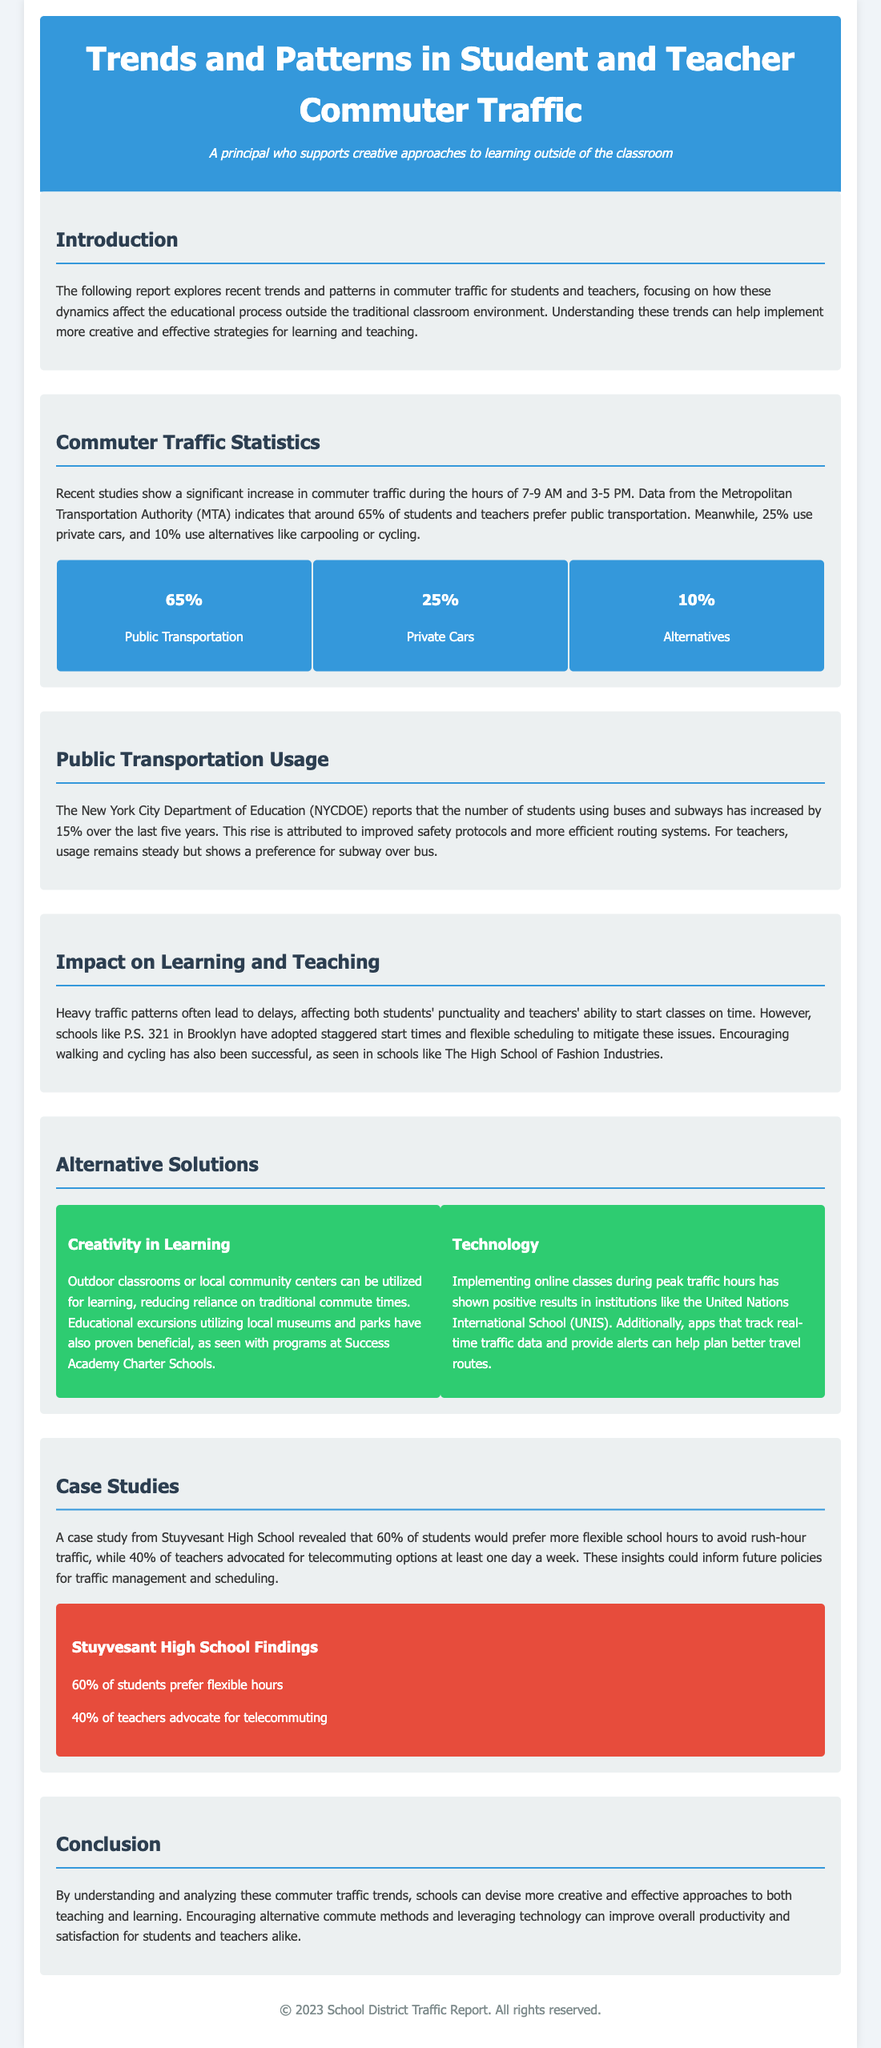What is the percentage of students and teachers using public transportation? The document states that around 65% of students and teachers prefer public transportation.
Answer: 65% What traffic peak hours are mentioned in the report? The report highlights significant increases in traffic during the hours of 7-9 AM and 3-5 PM.
Answer: 7-9 AM and 3-5 PM By what percentage has public transportation usage among students increased over the last five years? The New York City Department of Education reports a 15% increase in student usage of public transportation over the last five years.
Answer: 15% What is a proposed alternative commuting method mentioned in the document? The report suggests outdoor classrooms or educational excursions utilizing local museums and parks as alternatives to traditional commuting.
Answer: Outdoor classrooms What is the case study focused on? The case study highlights the preferences of students and teachers at Stuyvesant High School regarding flexible school hours and telecommuting.
Answer: Stuyvesant High School What percentage of teachers advocated for telecommuting options? According to the case study findings, 40% of teachers supported telecommuting options at least one day a week.
Answer: 40% What effect do heavy traffic patterns have according to the report? The document states that heavy traffic patterns often lead to delays affecting students' punctuality and teachers' ability to start classes on time.
Answer: Delays What creative strategy have some schools adopted to alleviate traffic issues? The report mentions that schools like P.S. 321 in Brooklyn have adopted staggered start times and flexible scheduling to mitigate the traffic problems.
Answer: Staggered start times What technology solution is suggested in the report? The document indicates that implementing online classes during peak traffic hours has shown positive results in some institutions.
Answer: Online classes 